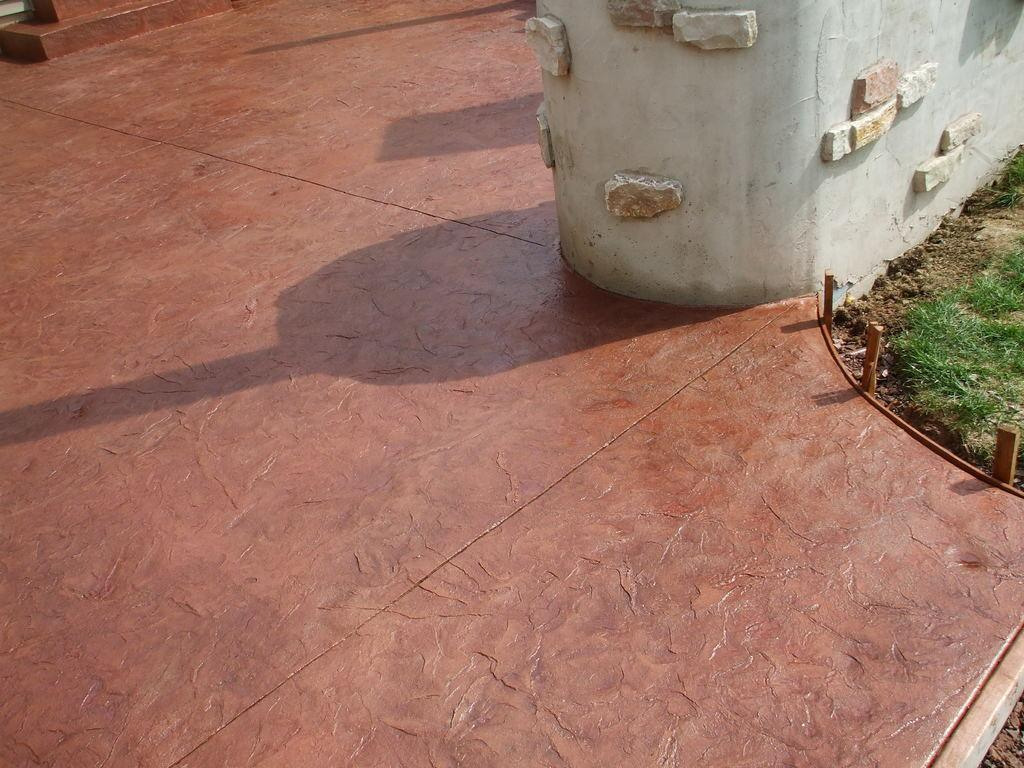What type of surface can be seen in the image? There is a brown path and a grass surface visible in the image. What is the color of the wall in the image? The wall in the image is white. What material is associated with the wall? There are stones associated with the wall. What type of pen is visible on the grass surface in the image? There is no pen present on the grass surface in the image. How many ducks are sitting on the stones associated with the wall? There are no ducks present in the image. 